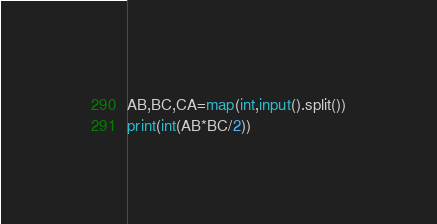<code> <loc_0><loc_0><loc_500><loc_500><_Python_>AB,BC,CA=map(int,input().split())
print(int(AB*BC/2))
</code> 